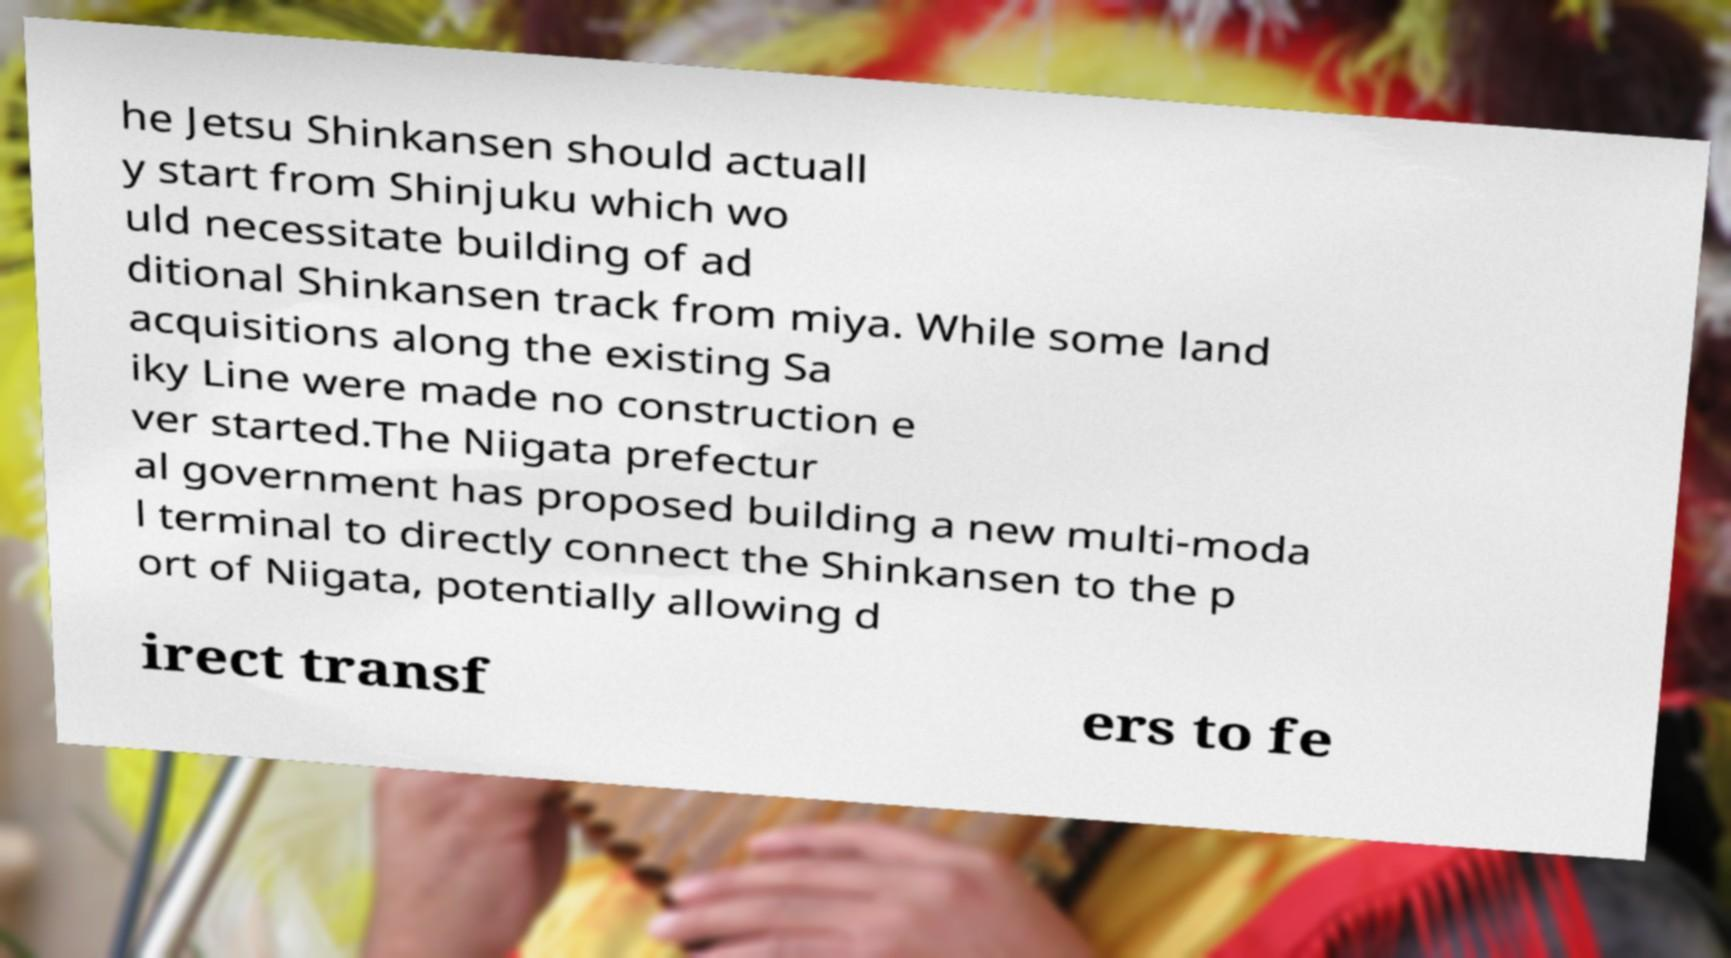Can you read and provide the text displayed in the image?This photo seems to have some interesting text. Can you extract and type it out for me? he Jetsu Shinkansen should actuall y start from Shinjuku which wo uld necessitate building of ad ditional Shinkansen track from miya. While some land acquisitions along the existing Sa iky Line were made no construction e ver started.The Niigata prefectur al government has proposed building a new multi-moda l terminal to directly connect the Shinkansen to the p ort of Niigata, potentially allowing d irect transf ers to fe 